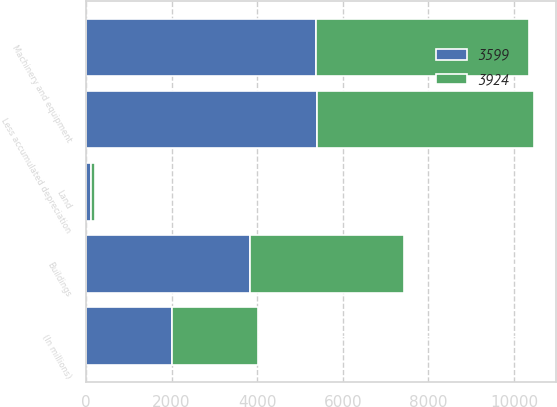Convert chart. <chart><loc_0><loc_0><loc_500><loc_500><stacked_bar_chart><ecel><fcel>(In millions)<fcel>Land<fcel>Buildings<fcel>Machinery and equipment<fcel>Less accumulated depreciation<nl><fcel>3599<fcel>2005<fcel>112<fcel>3828<fcel>5384<fcel>5400<nl><fcel>3924<fcel>2004<fcel>95<fcel>3593<fcel>4972<fcel>5061<nl></chart> 